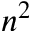<formula> <loc_0><loc_0><loc_500><loc_500>n ^ { 2 }</formula> 